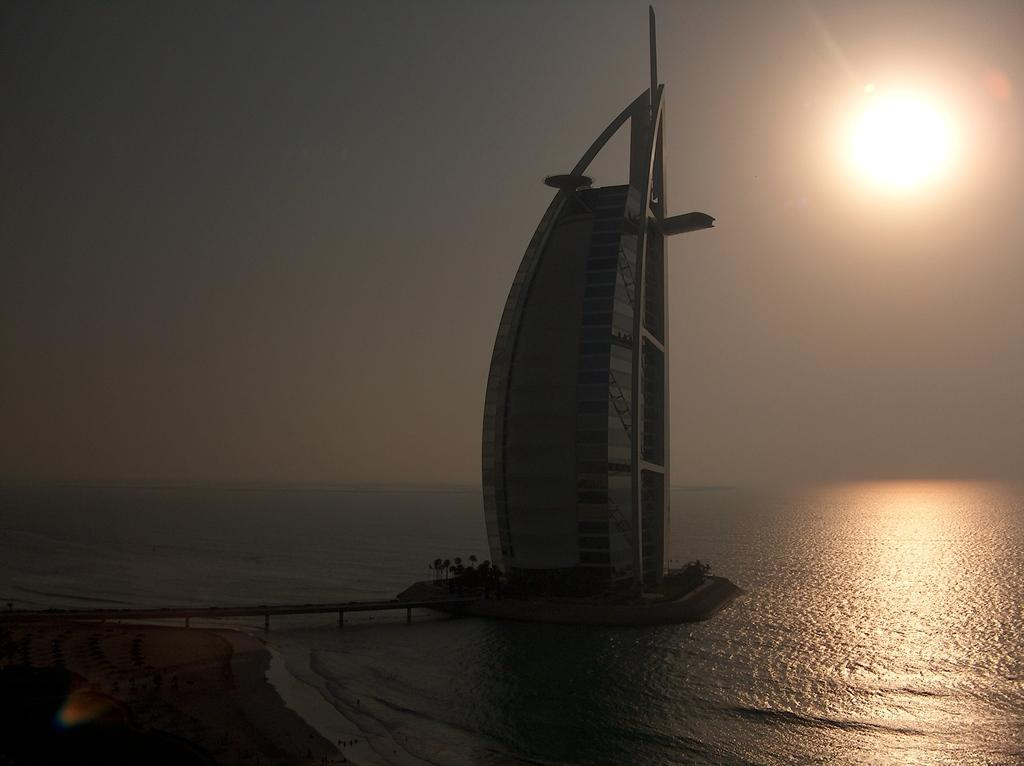What is the main subject in the middle of the image? There is a boat in the middle of the image. What can be seen on the right side of the image? The sun is visible on the right side of the image. What type of environment is depicted in the image? There is water in the image, suggesting a water-based environment. What type of books can be found in the library depicted in the image? There is no library present in the image; it features a boat and water. Can you tell me the name of the lawyer who is advising the company in the image? There is no company or lawyer present in the image; it features a boat and water. 